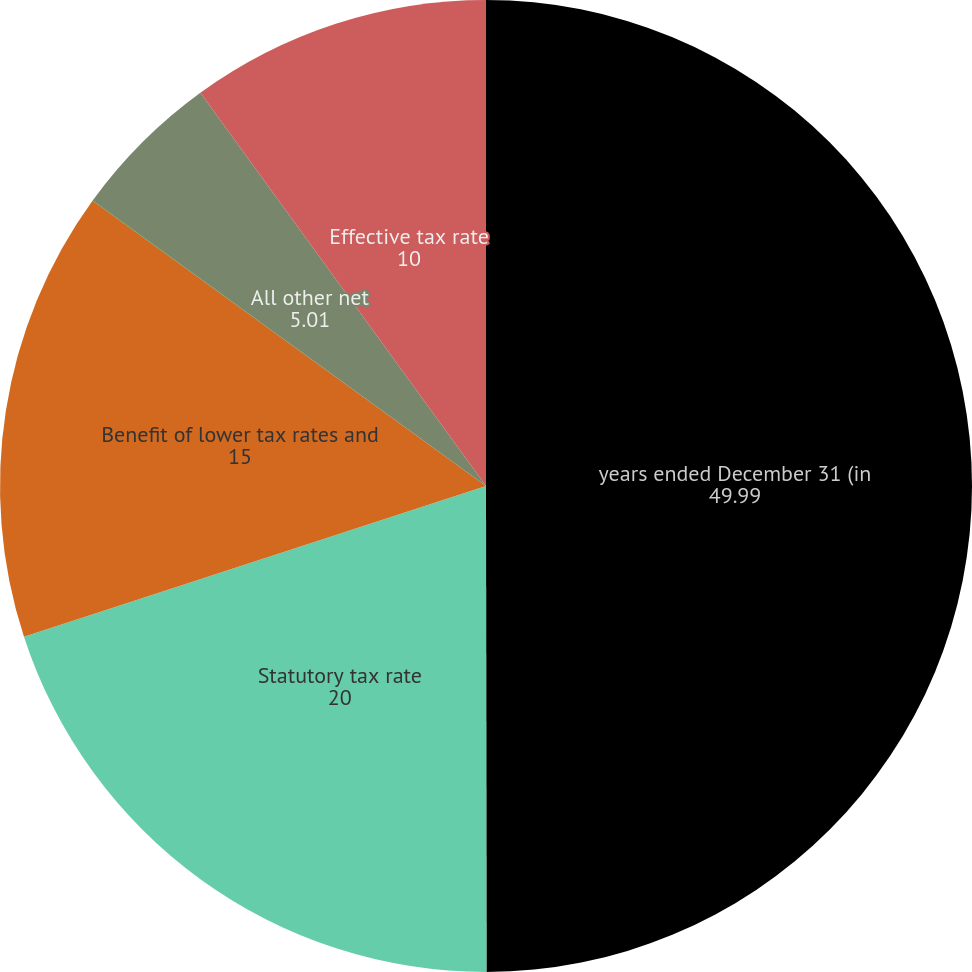Convert chart. <chart><loc_0><loc_0><loc_500><loc_500><pie_chart><fcel>years ended December 31 (in<fcel>Statutory tax rate<fcel>Benefit of lower tax rates and<fcel>State taxes net of federal<fcel>All other net<fcel>Effective tax rate<nl><fcel>49.99%<fcel>20.0%<fcel>15.0%<fcel>0.01%<fcel>5.01%<fcel>10.0%<nl></chart> 